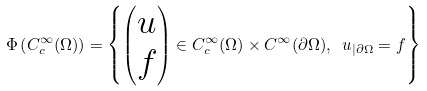<formula> <loc_0><loc_0><loc_500><loc_500>\Phi \left ( C ^ { \infty } _ { c } ( \Omega ) \right ) = \left \{ \begin{pmatrix} u \\ f \end{pmatrix} \in C ^ { \infty } _ { c } ( \Omega ) \times C ^ { \infty } ( \partial \Omega ) , \ u _ { | \partial \Omega } = f \right \}</formula> 